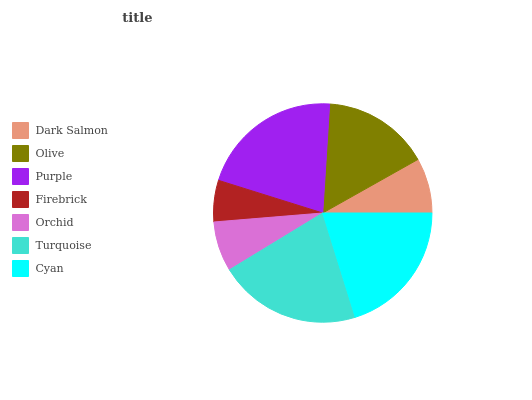Is Firebrick the minimum?
Answer yes or no. Yes. Is Purple the maximum?
Answer yes or no. Yes. Is Olive the minimum?
Answer yes or no. No. Is Olive the maximum?
Answer yes or no. No. Is Olive greater than Dark Salmon?
Answer yes or no. Yes. Is Dark Salmon less than Olive?
Answer yes or no. Yes. Is Dark Salmon greater than Olive?
Answer yes or no. No. Is Olive less than Dark Salmon?
Answer yes or no. No. Is Olive the high median?
Answer yes or no. Yes. Is Olive the low median?
Answer yes or no. Yes. Is Cyan the high median?
Answer yes or no. No. Is Purple the low median?
Answer yes or no. No. 